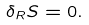<formula> <loc_0><loc_0><loc_500><loc_500>\delta _ { R } S = 0 .</formula> 